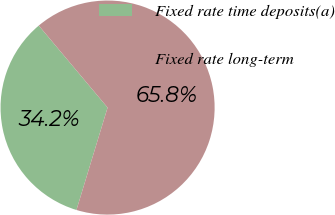<chart> <loc_0><loc_0><loc_500><loc_500><pie_chart><fcel>Fixed rate time deposits(a)<fcel>Fixed rate long-term<nl><fcel>34.19%<fcel>65.81%<nl></chart> 